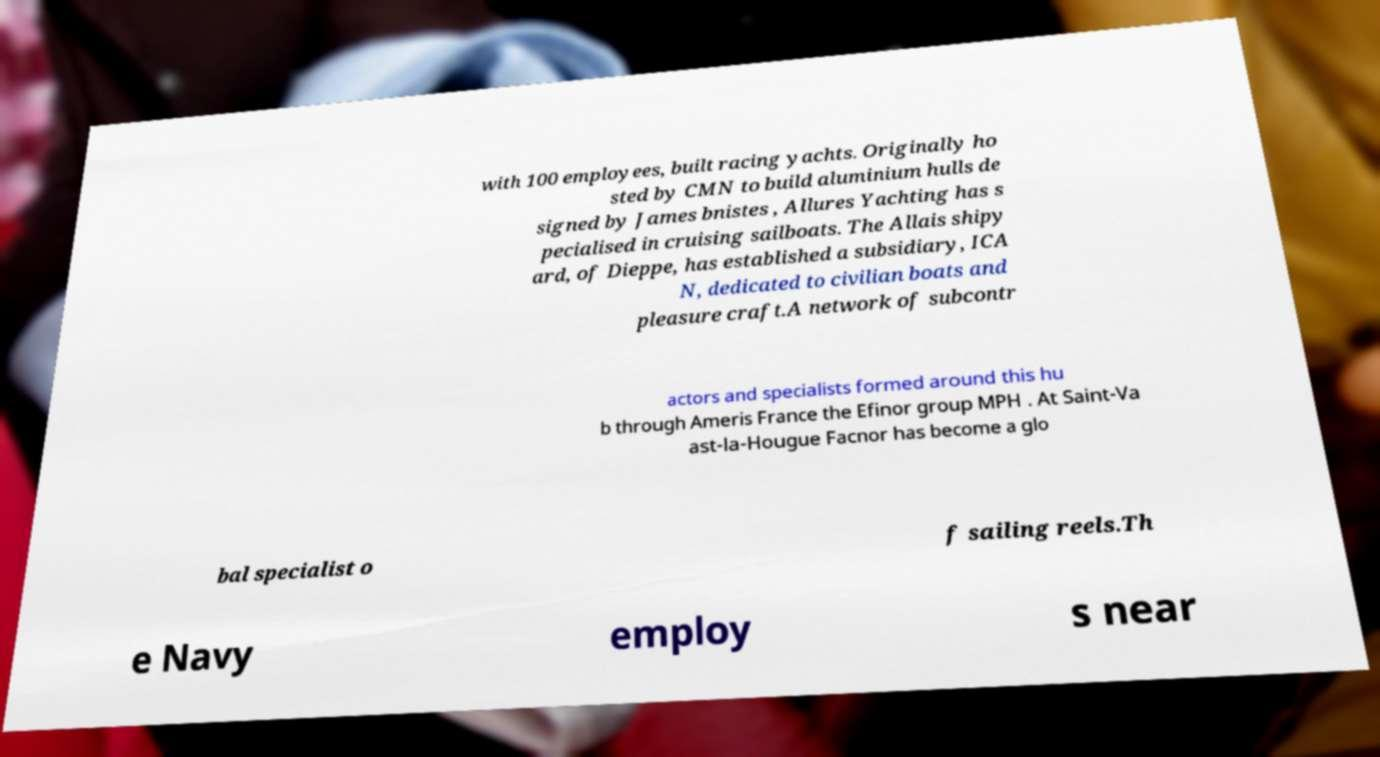Can you accurately transcribe the text from the provided image for me? with 100 employees, built racing yachts. Originally ho sted by CMN to build aluminium hulls de signed by James bnistes , Allures Yachting has s pecialised in cruising sailboats. The Allais shipy ard, of Dieppe, has established a subsidiary, ICA N, dedicated to civilian boats and pleasure craft.A network of subcontr actors and specialists formed around this hu b through Ameris France the Efinor group MPH . At Saint-Va ast-la-Hougue Facnor has become a glo bal specialist o f sailing reels.Th e Navy employ s near 